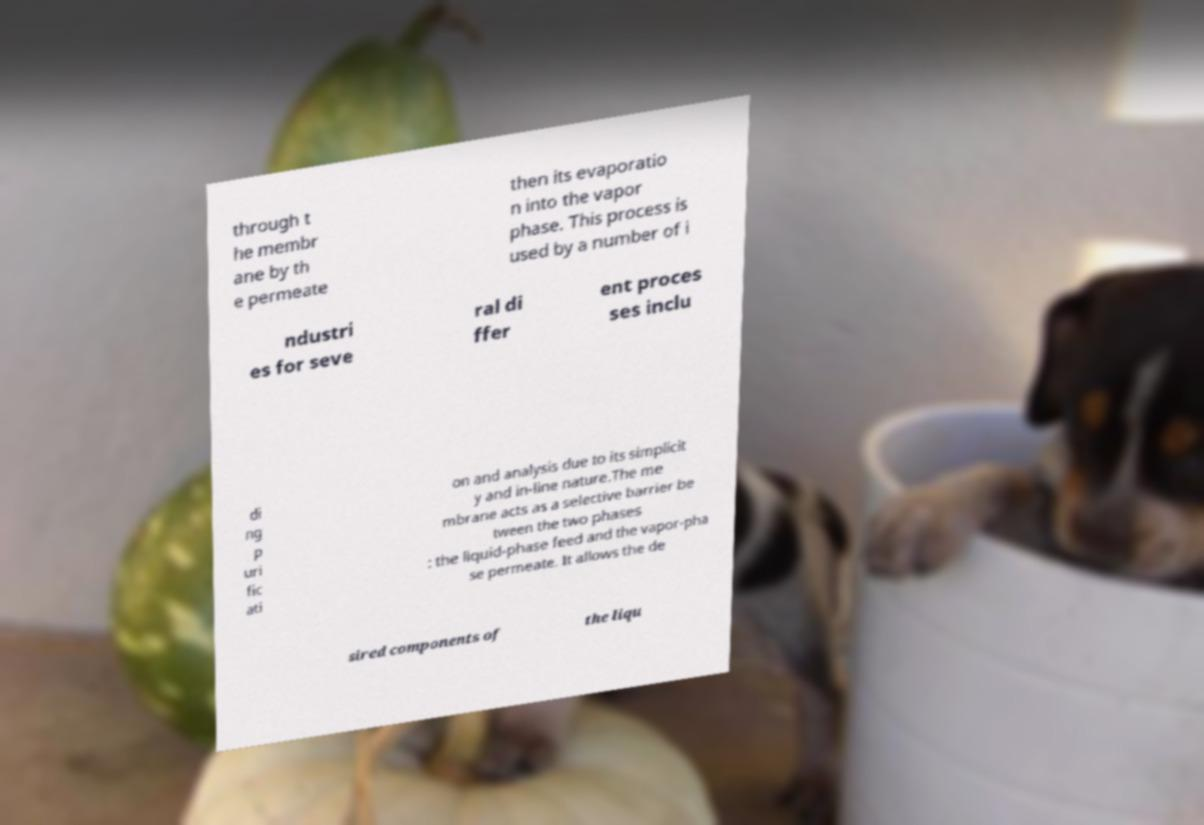There's text embedded in this image that I need extracted. Can you transcribe it verbatim? through t he membr ane by th e permeate then its evaporatio n into the vapor phase. This process is used by a number of i ndustri es for seve ral di ffer ent proces ses inclu di ng p uri fic ati on and analysis due to its simplicit y and in-line nature.The me mbrane acts as a selective barrier be tween the two phases : the liquid-phase feed and the vapor-pha se permeate. It allows the de sired components of the liqu 